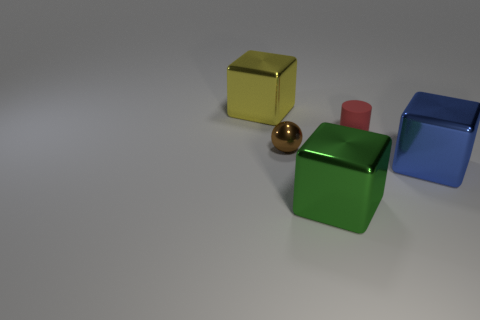Add 3 big yellow metallic spheres. How many objects exist? 8 Subtract all blocks. How many objects are left? 2 Add 4 spheres. How many spheres are left? 5 Add 4 brown metallic balls. How many brown metallic balls exist? 5 Subtract 0 red spheres. How many objects are left? 5 Subtract all big purple cubes. Subtract all metallic cubes. How many objects are left? 2 